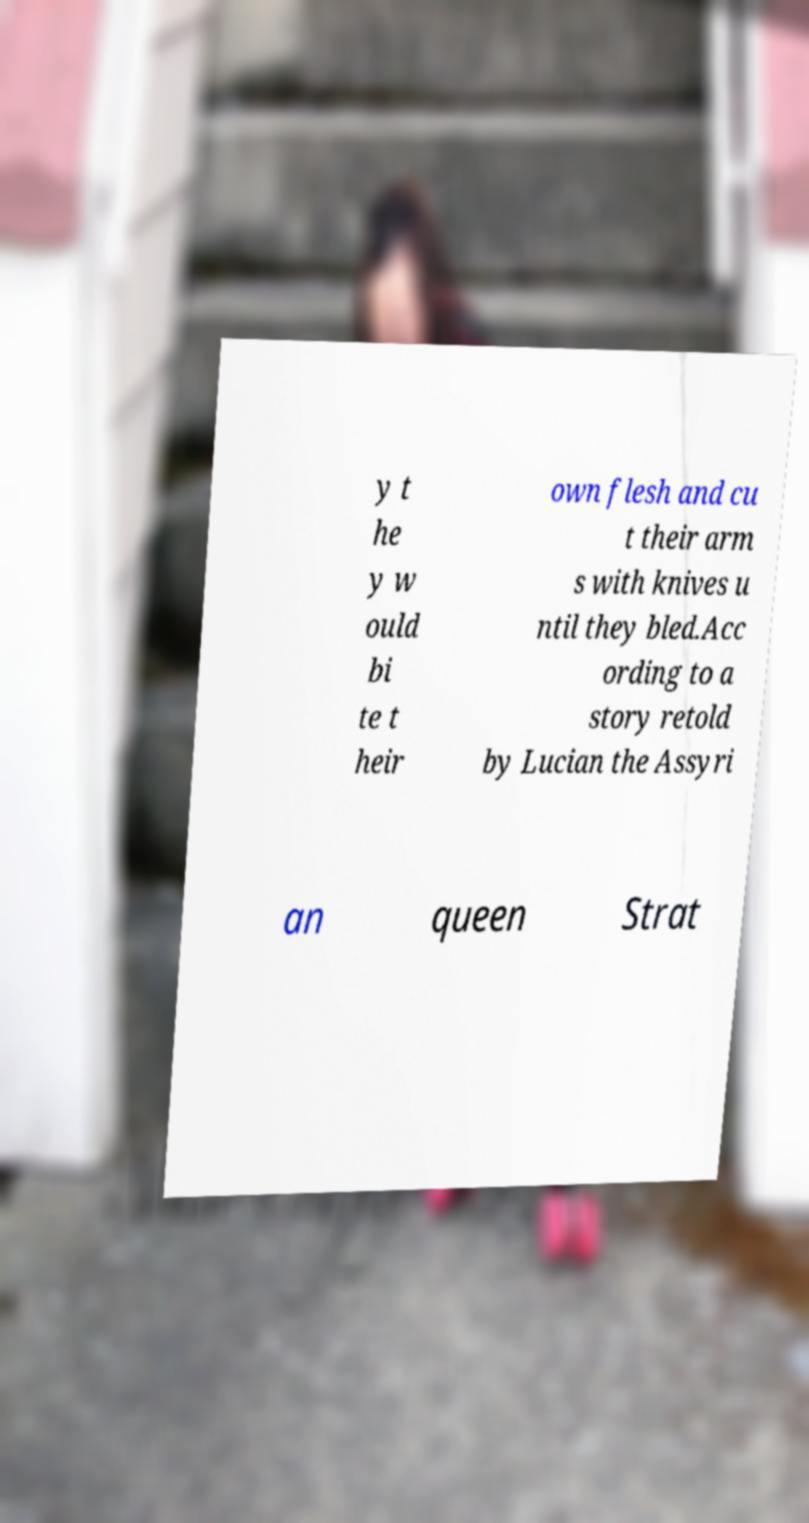For documentation purposes, I need the text within this image transcribed. Could you provide that? y t he y w ould bi te t heir own flesh and cu t their arm s with knives u ntil they bled.Acc ording to a story retold by Lucian the Assyri an queen Strat 